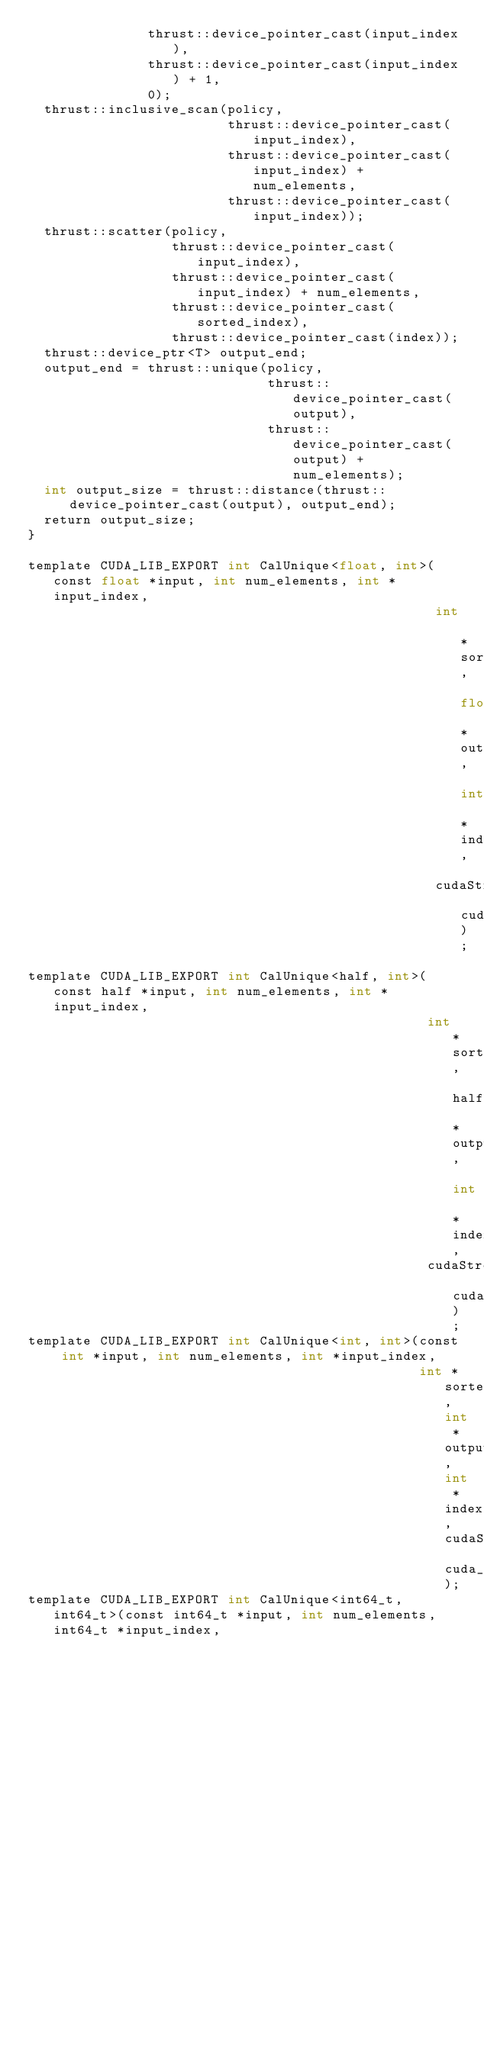<code> <loc_0><loc_0><loc_500><loc_500><_Cuda_>               thrust::device_pointer_cast(input_index),
               thrust::device_pointer_cast(input_index) + 1,
               0);
  thrust::inclusive_scan(policy,
                         thrust::device_pointer_cast(input_index),
                         thrust::device_pointer_cast(input_index) + num_elements,
                         thrust::device_pointer_cast(input_index));
  thrust::scatter(policy,
                  thrust::device_pointer_cast(input_index),
                  thrust::device_pointer_cast(input_index) + num_elements,
                  thrust::device_pointer_cast(sorted_index),
                  thrust::device_pointer_cast(index));
  thrust::device_ptr<T> output_end;
  output_end = thrust::unique(policy,
                              thrust::device_pointer_cast(output),
                              thrust::device_pointer_cast(output) + num_elements);
  int output_size = thrust::distance(thrust::device_pointer_cast(output), output_end);
  return output_size;
}

template CUDA_LIB_EXPORT int CalUnique<float, int>(const float *input, int num_elements, int *input_index,
                                                   int *sorted_index, float *output, int *index,
                                                   cudaStream_t cuda_stream);
template CUDA_LIB_EXPORT int CalUnique<half, int>(const half *input, int num_elements, int *input_index,
                                                  int *sorted_index, half *output, int *index,
                                                  cudaStream_t cuda_stream);
template CUDA_LIB_EXPORT int CalUnique<int, int>(const int *input, int num_elements, int *input_index,
                                                 int *sorted_index, int *output, int *index, cudaStream_t cuda_stream);
template CUDA_LIB_EXPORT int CalUnique<int64_t, int64_t>(const int64_t *input, int num_elements, int64_t *input_index,
                                                         int64_t *sorted_index, int64_t *output, int64_t *index,
                                                         cudaStream_t cuda_stream);
</code> 